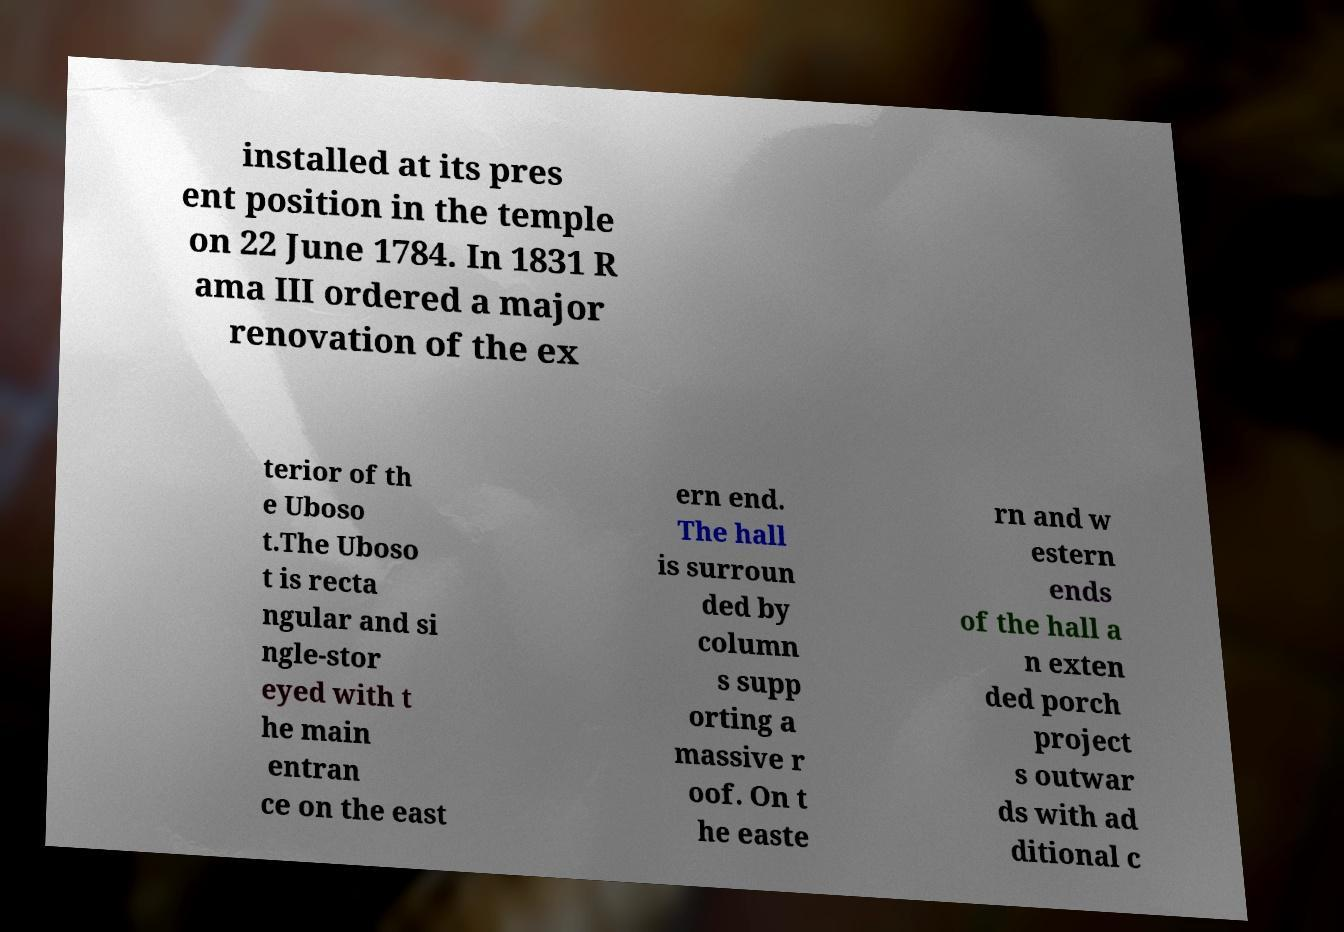Can you accurately transcribe the text from the provided image for me? installed at its pres ent position in the temple on 22 June 1784. In 1831 R ama III ordered a major renovation of the ex terior of th e Uboso t.The Uboso t is recta ngular and si ngle-stor eyed with t he main entran ce on the east ern end. The hall is surroun ded by column s supp orting a massive r oof. On t he easte rn and w estern ends of the hall a n exten ded porch project s outwar ds with ad ditional c 